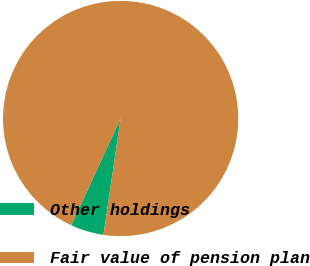Convert chart. <chart><loc_0><loc_0><loc_500><loc_500><pie_chart><fcel>Other holdings<fcel>Fair value of pension plan<nl><fcel>4.56%<fcel>95.44%<nl></chart> 